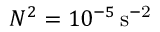<formula> <loc_0><loc_0><loc_500><loc_500>N ^ { 2 } = 1 0 ^ { - 5 } \, { s ^ { - 2 } }</formula> 